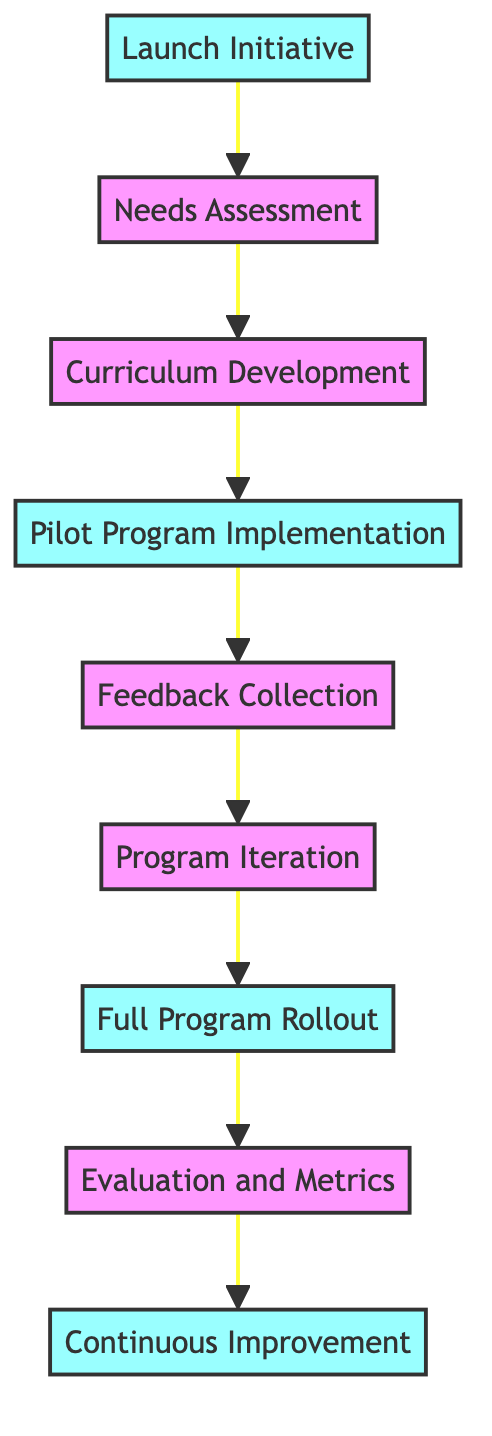What is the first step in the project timeline? The first step is marked as "Launch Initiative" which is the starting point of the directed graph.
Answer: Launch Initiative How many nodes are present in the diagram? By counting each unique point in the diagram, we find there are nine nodes that represent different milestones or activities.
Answer: 9 What is the last milestone before Continuous Improvement? The milestone directly leading to "Continuous Improvement" is "Evaluation and Metrics," which precedes it in the flow of the diagram.
Answer: Evaluation and Metrics Which two nodes are connected by the edge from the Pilot Program Implementation? The node "Pilot Program Implementation" is connected by an edge to "Feedback Collection," indicating the next step in the process after the pilot program.
Answer: Feedback Collection What is the relationship between Needs Assessment and Curriculum Development? The diagram shows a direct connection (edge) from "Needs Assessment" leading to "Curriculum Development," indicating that Curriculum Development follows Needs Assessment.
Answer: Needs Assessment leads to Curriculum Development What is the total number of edges in the diagram? By examining the connections between nodes, we count a total of eight edges that represent the flow from one milestone to the next in the project timeline.
Answer: 8 Which milestone is the fourth in the sequence? The fourth step in the sequence, derived from tracing the flow from the beginning, is "Pilot Program Implementation."
Answer: Pilot Program Implementation What are the three milestones highlighted in the diagram? The three milestones are the initiating step "Launch Initiative," the mid-stage "Full Program Rollout," and the final step "Continuous Improvement."
Answer: Launch Initiative, Full Program Rollout, Continuous Improvement What follows after Program Iteration in the diagram? The next step following "Program Iteration" is "Full Program Rollout," indicating that once iteration is complete, the program is rolled out fully.
Answer: Full Program Rollout 